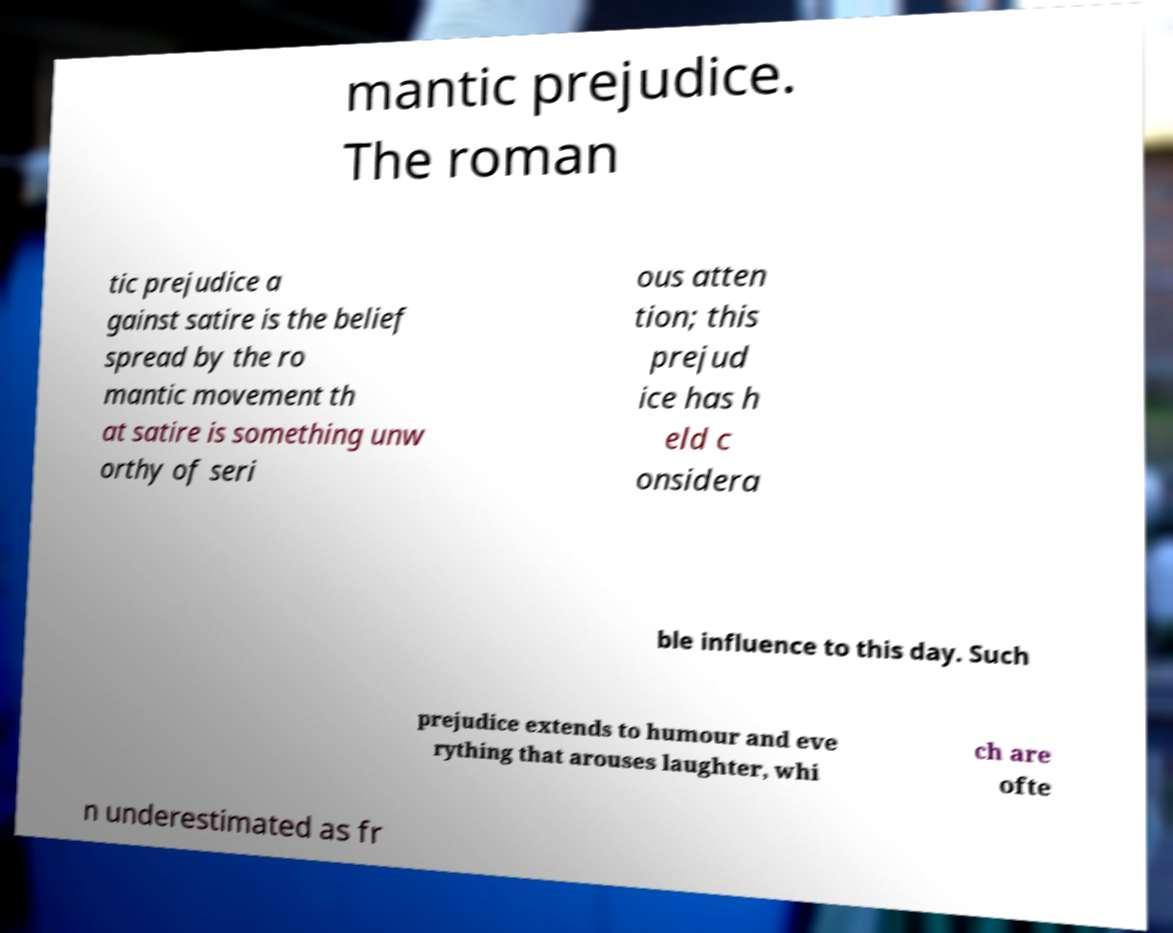I need the written content from this picture converted into text. Can you do that? mantic prejudice. The roman tic prejudice a gainst satire is the belief spread by the ro mantic movement th at satire is something unw orthy of seri ous atten tion; this prejud ice has h eld c onsidera ble influence to this day. Such prejudice extends to humour and eve rything that arouses laughter, whi ch are ofte n underestimated as fr 